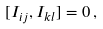Convert formula to latex. <formula><loc_0><loc_0><loc_500><loc_500>[ I _ { i j } , I _ { k l } ] = 0 \, ,</formula> 